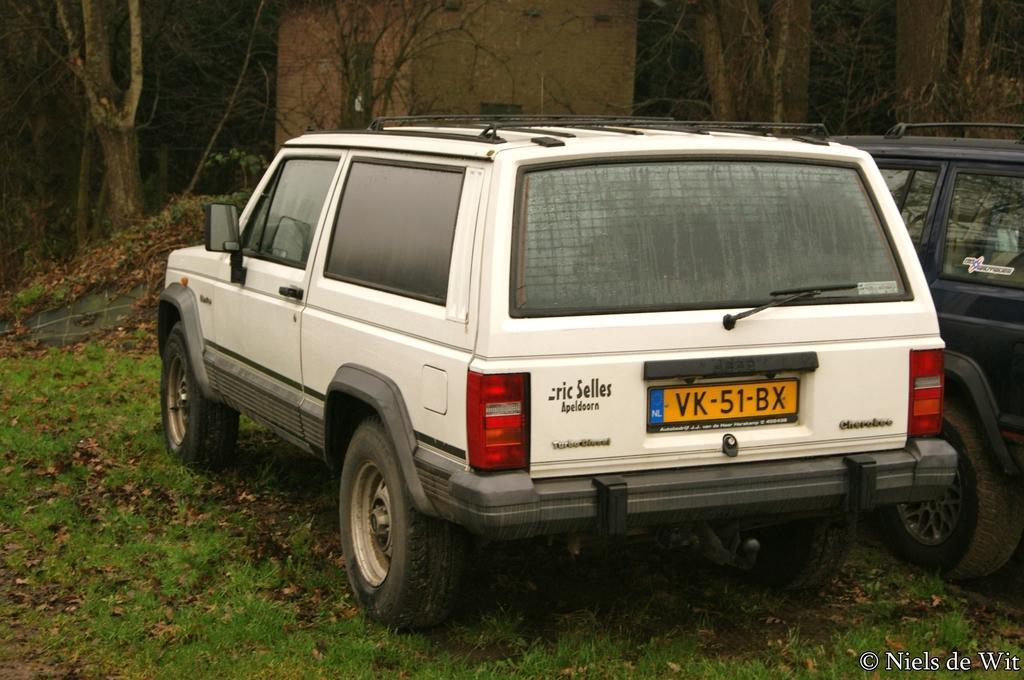Describe this image in one or two sentences. In this image we can see some cars placed on the ground. We can also see some grass, a group of trees and a building. 